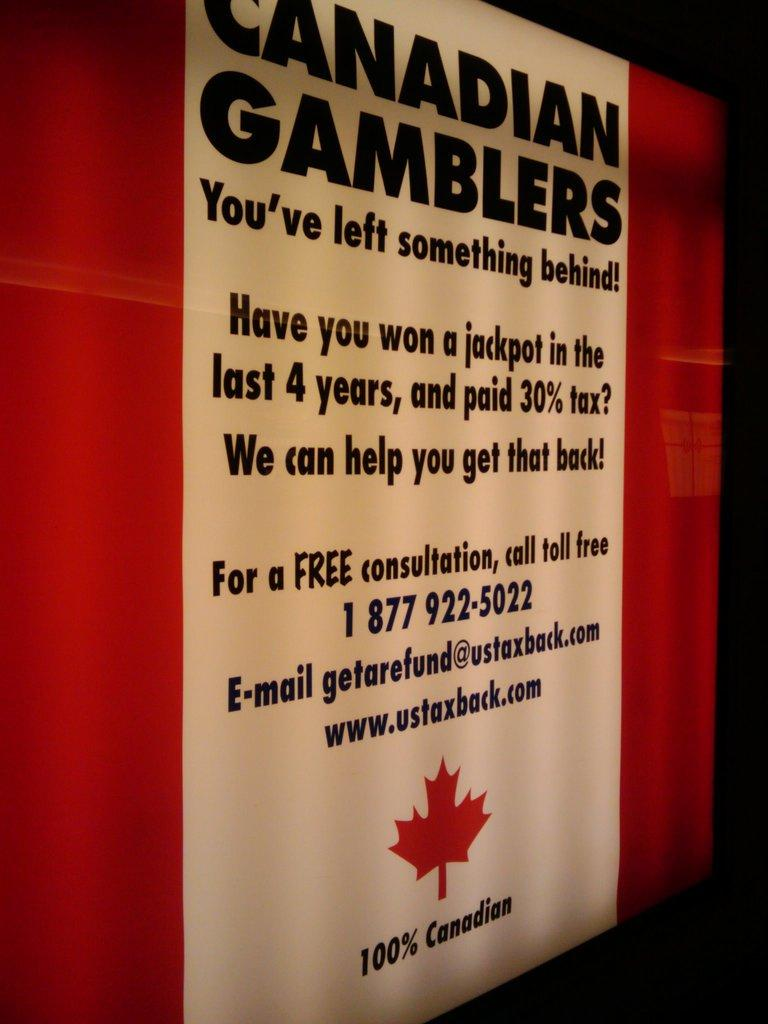<image>
Summarize the visual content of the image. a poster for the Canadian Gamblers You've left something behind 